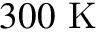Convert formula to latex. <formula><loc_0><loc_0><loc_500><loc_500>3 0 0 K</formula> 